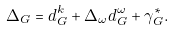Convert formula to latex. <formula><loc_0><loc_0><loc_500><loc_500>\Delta _ { G } = d _ { G } ^ { k } + \Delta _ { \omega } d _ { G } ^ { \omega } + \gamma _ { G } ^ { * } .</formula> 